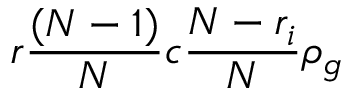<formula> <loc_0><loc_0><loc_500><loc_500>r \frac { ( N - 1 ) } { N } c \frac { N - r _ { i } } { N } \rho _ { g }</formula> 